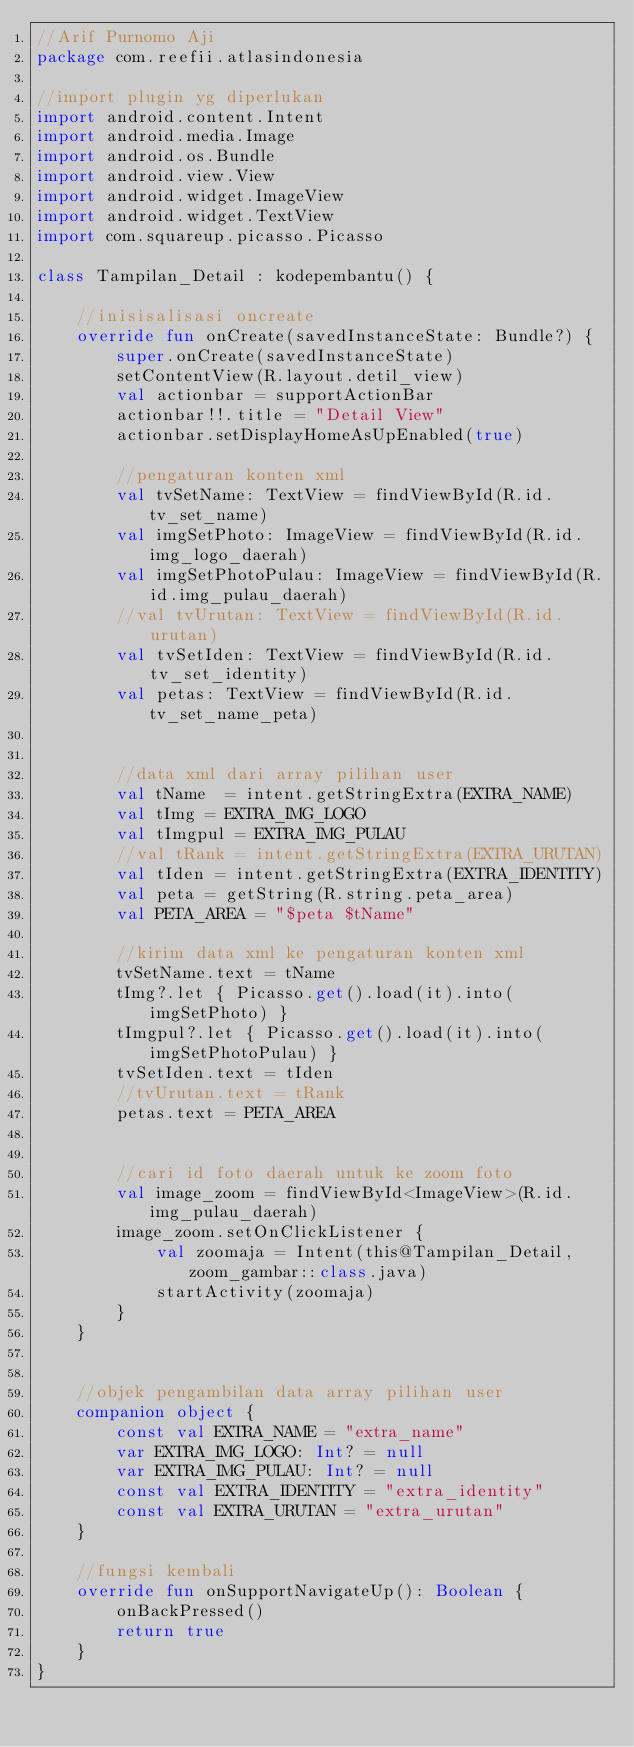<code> <loc_0><loc_0><loc_500><loc_500><_Kotlin_>//Arif Purnomo Aji
package com.reefii.atlasindonesia

//import plugin yg diperlukan
import android.content.Intent
import android.media.Image
import android.os.Bundle
import android.view.View
import android.widget.ImageView
import android.widget.TextView
import com.squareup.picasso.Picasso

class Tampilan_Detail : kodepembantu() {

    //inisisalisasi oncreate
    override fun onCreate(savedInstanceState: Bundle?) {
        super.onCreate(savedInstanceState)
        setContentView(R.layout.detil_view)
        val actionbar = supportActionBar
        actionbar!!.title = "Detail View"
        actionbar.setDisplayHomeAsUpEnabled(true)

        //pengaturan konten xml
        val tvSetName: TextView = findViewById(R.id.tv_set_name)
        val imgSetPhoto: ImageView = findViewById(R.id.img_logo_daerah)
        val imgSetPhotoPulau: ImageView = findViewById(R.id.img_pulau_daerah)
        //val tvUrutan: TextView = findViewById(R.id.urutan)
        val tvSetIden: TextView = findViewById(R.id.tv_set_identity)
        val petas: TextView = findViewById(R.id.tv_set_name_peta)


        //data xml dari array pilihan user
        val tName  = intent.getStringExtra(EXTRA_NAME)
        val tImg = EXTRA_IMG_LOGO
        val tImgpul = EXTRA_IMG_PULAU
        //val tRank = intent.getStringExtra(EXTRA_URUTAN)
        val tIden = intent.getStringExtra(EXTRA_IDENTITY)
        val peta = getString(R.string.peta_area)
        val PETA_AREA = "$peta $tName"

        //kirim data xml ke pengaturan konten xml
        tvSetName.text = tName
        tImg?.let { Picasso.get().load(it).into(imgSetPhoto) }
        tImgpul?.let { Picasso.get().load(it).into(imgSetPhotoPulau) }
        tvSetIden.text = tIden
        //tvUrutan.text = tRank
        petas.text = PETA_AREA


        //cari id foto daerah untuk ke zoom foto
        val image_zoom = findViewById<ImageView>(R.id.img_pulau_daerah)
        image_zoom.setOnClickListener {
            val zoomaja = Intent(this@Tampilan_Detail, zoom_gambar::class.java)
            startActivity(zoomaja)
        }
    }


    //objek pengambilan data array pilihan user
    companion object {
        const val EXTRA_NAME = "extra_name"
        var EXTRA_IMG_LOGO: Int? = null
        var EXTRA_IMG_PULAU: Int? = null
        const val EXTRA_IDENTITY = "extra_identity"
        const val EXTRA_URUTAN = "extra_urutan"
    }

    //fungsi kembali
    override fun onSupportNavigateUp(): Boolean {
        onBackPressed()
        return true
    }
}
</code> 